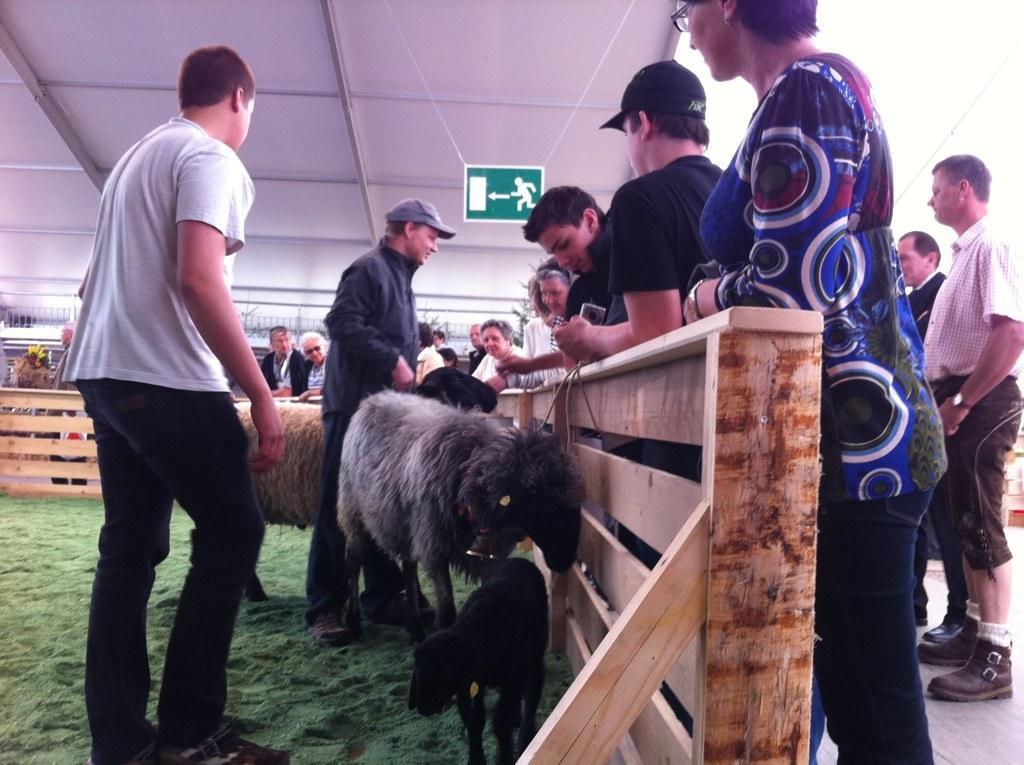Please provide a concise description of this image. In this image I can see animals standing in front of the wooden fence and there are two persons standing in front of animals and back side of the fence I can see few persons and a sign board attached to the roof in the middle. 